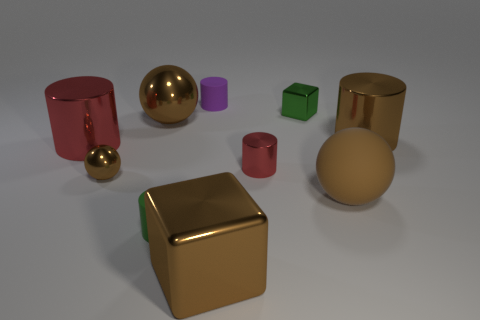What material is the small cylinder left of the rubber cylinder that is behind the red cylinder right of the big brown metallic block?
Offer a very short reply. Rubber. What number of objects are either green objects that are left of the green block or metal cylinders in front of the brown metallic cylinder?
Your answer should be very brief. 3. There is a large brown thing that is the same shape as the big red object; what is it made of?
Provide a succinct answer. Metal. How many shiny objects are either large cylinders or brown cubes?
Your answer should be very brief. 3. What is the shape of the small brown object that is made of the same material as the green cube?
Your response must be concise. Sphere. How many large red objects have the same shape as the small green metallic thing?
Provide a succinct answer. 0. Does the red thing that is on the right side of the big red cylinder have the same shape as the big metal thing that is left of the big metallic sphere?
Offer a terse response. Yes. What number of things are either tiny brown shiny objects or matte cylinders in front of the tiny red object?
Offer a very short reply. 2. There is a tiny object that is the same color as the large shiny cube; what shape is it?
Provide a short and direct response. Sphere. How many other cylinders have the same size as the green matte cylinder?
Make the answer very short. 2. 